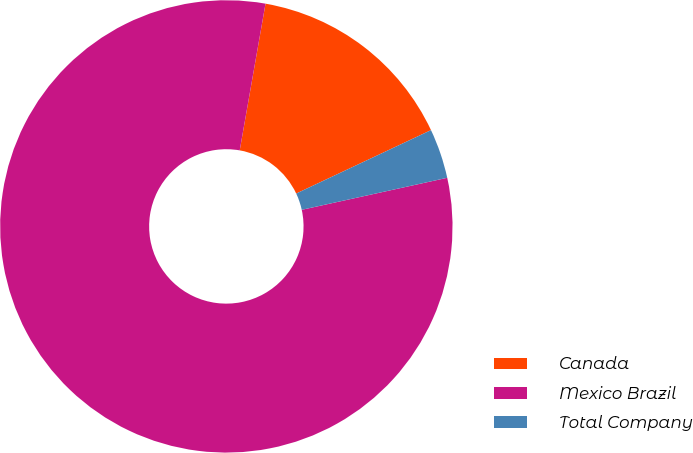Convert chart. <chart><loc_0><loc_0><loc_500><loc_500><pie_chart><fcel>Canada<fcel>Mexico Brazil<fcel>Total Company<nl><fcel>15.23%<fcel>81.22%<fcel>3.55%<nl></chart> 